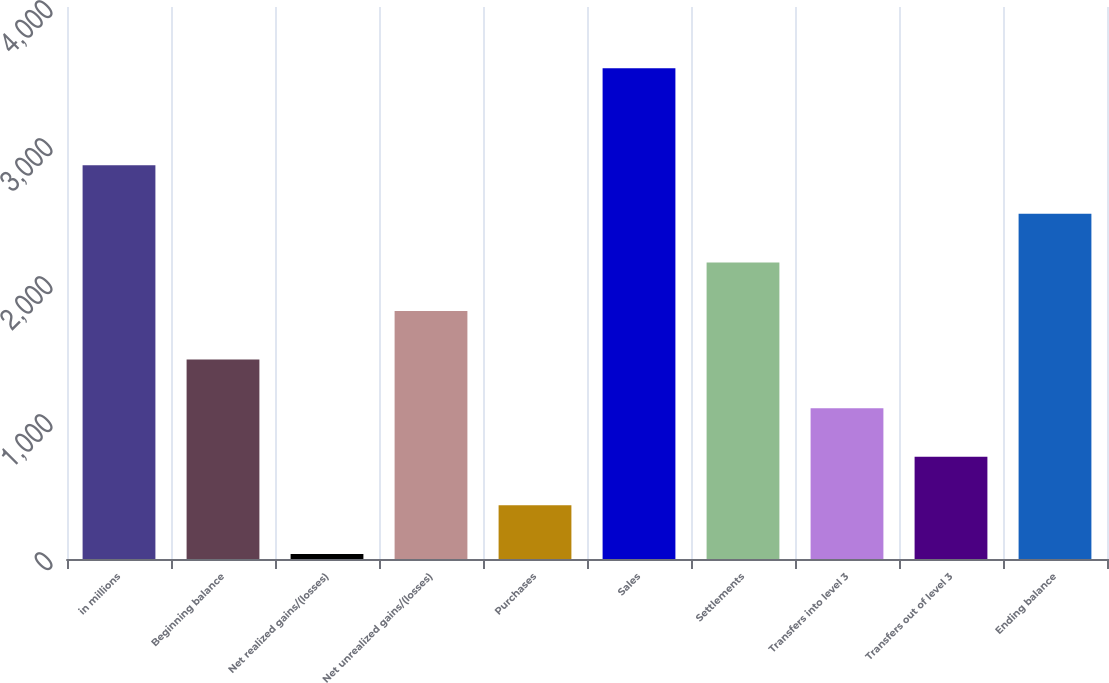<chart> <loc_0><loc_0><loc_500><loc_500><bar_chart><fcel>in millions<fcel>Beginning balance<fcel>Net realized gains/(losses)<fcel>Net unrealized gains/(losses)<fcel>Purchases<fcel>Sales<fcel>Settlements<fcel>Transfers into level 3<fcel>Transfers out of level 3<fcel>Ending balance<nl><fcel>2853<fcel>1445<fcel>37<fcel>1797<fcel>389<fcel>3557<fcel>2149<fcel>1093<fcel>741<fcel>2501<nl></chart> 